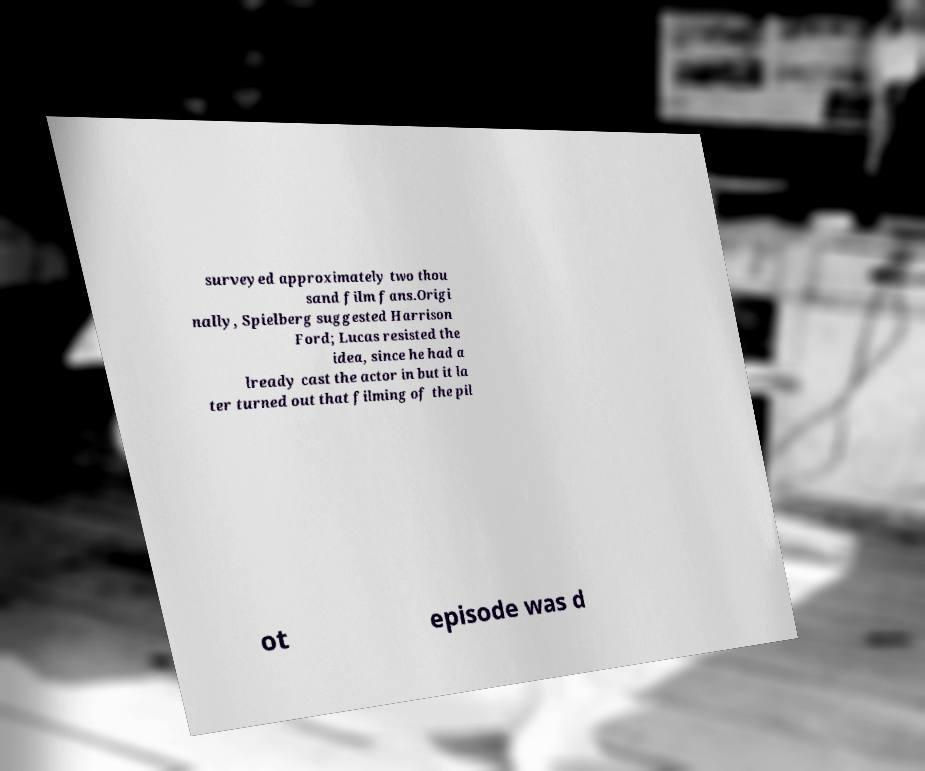Please read and relay the text visible in this image. What does it say? surveyed approximately two thou sand film fans.Origi nally, Spielberg suggested Harrison Ford; Lucas resisted the idea, since he had a lready cast the actor in but it la ter turned out that filming of the pil ot episode was d 